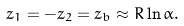Convert formula to latex. <formula><loc_0><loc_0><loc_500><loc_500>z _ { 1 } = - z _ { 2 } = z _ { b } \approx R \ln \alpha .</formula> 